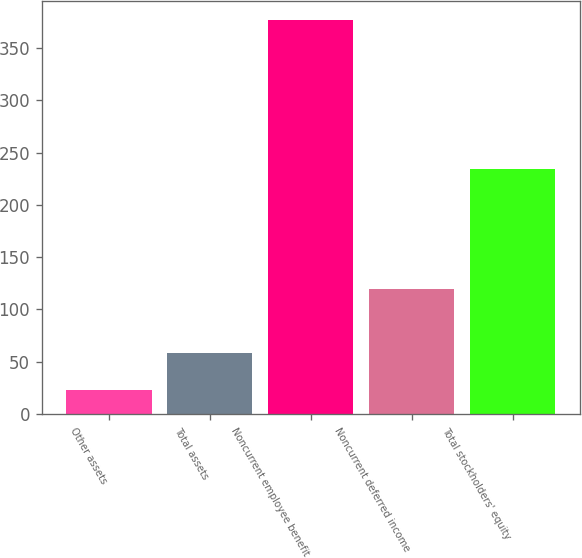<chart> <loc_0><loc_0><loc_500><loc_500><bar_chart><fcel>Other assets<fcel>Total assets<fcel>Noncurrent employee benefit<fcel>Noncurrent deferred income<fcel>Total stockholders' equity<nl><fcel>22.8<fcel>58.19<fcel>376.7<fcel>119.3<fcel>234.6<nl></chart> 